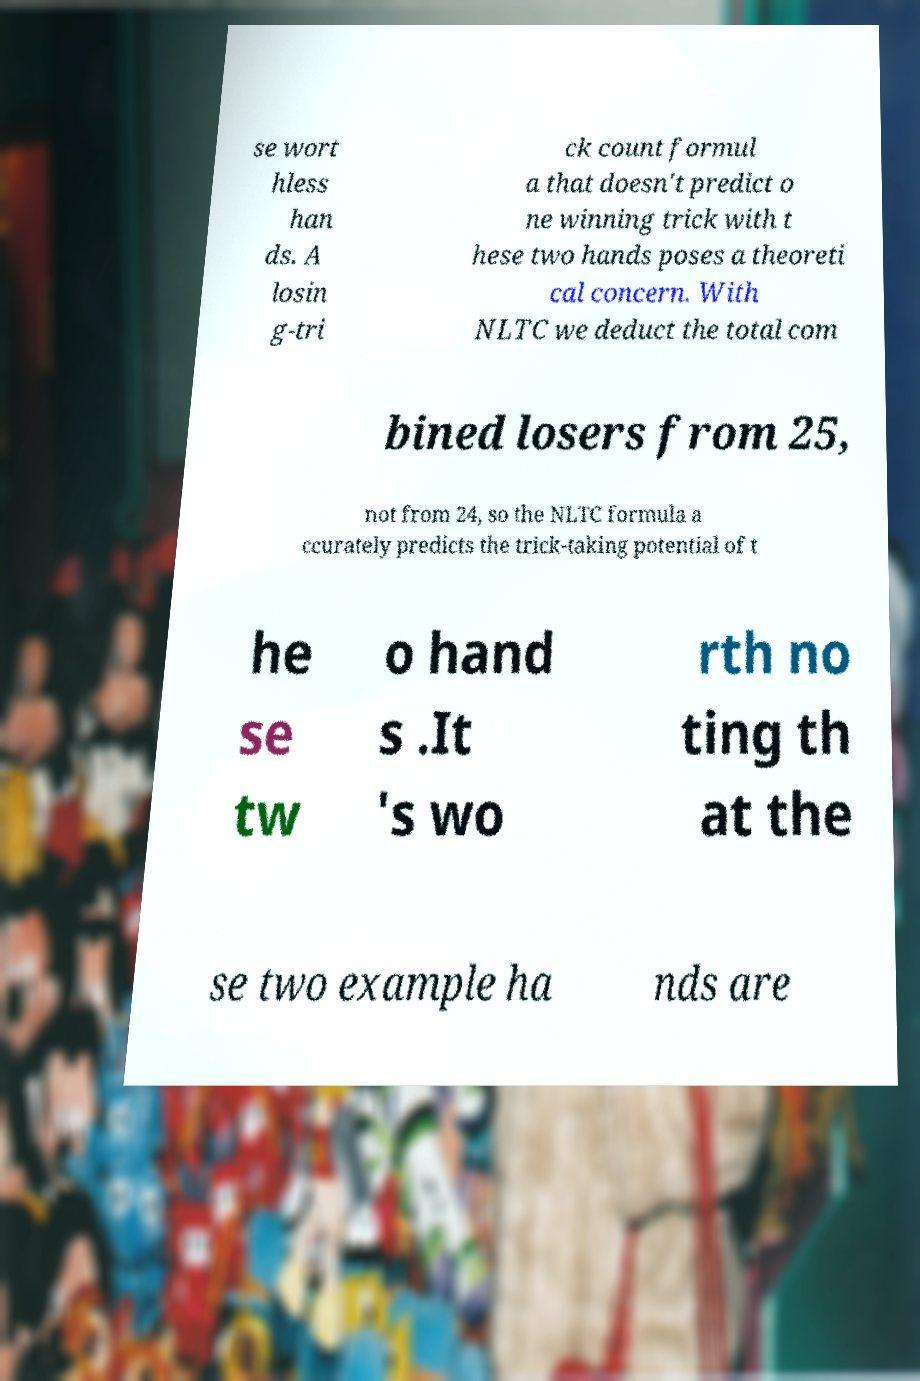Please read and relay the text visible in this image. What does it say? se wort hless han ds. A losin g-tri ck count formul a that doesn't predict o ne winning trick with t hese two hands poses a theoreti cal concern. With NLTC we deduct the total com bined losers from 25, not from 24, so the NLTC formula a ccurately predicts the trick-taking potential of t he se tw o hand s .It 's wo rth no ting th at the se two example ha nds are 